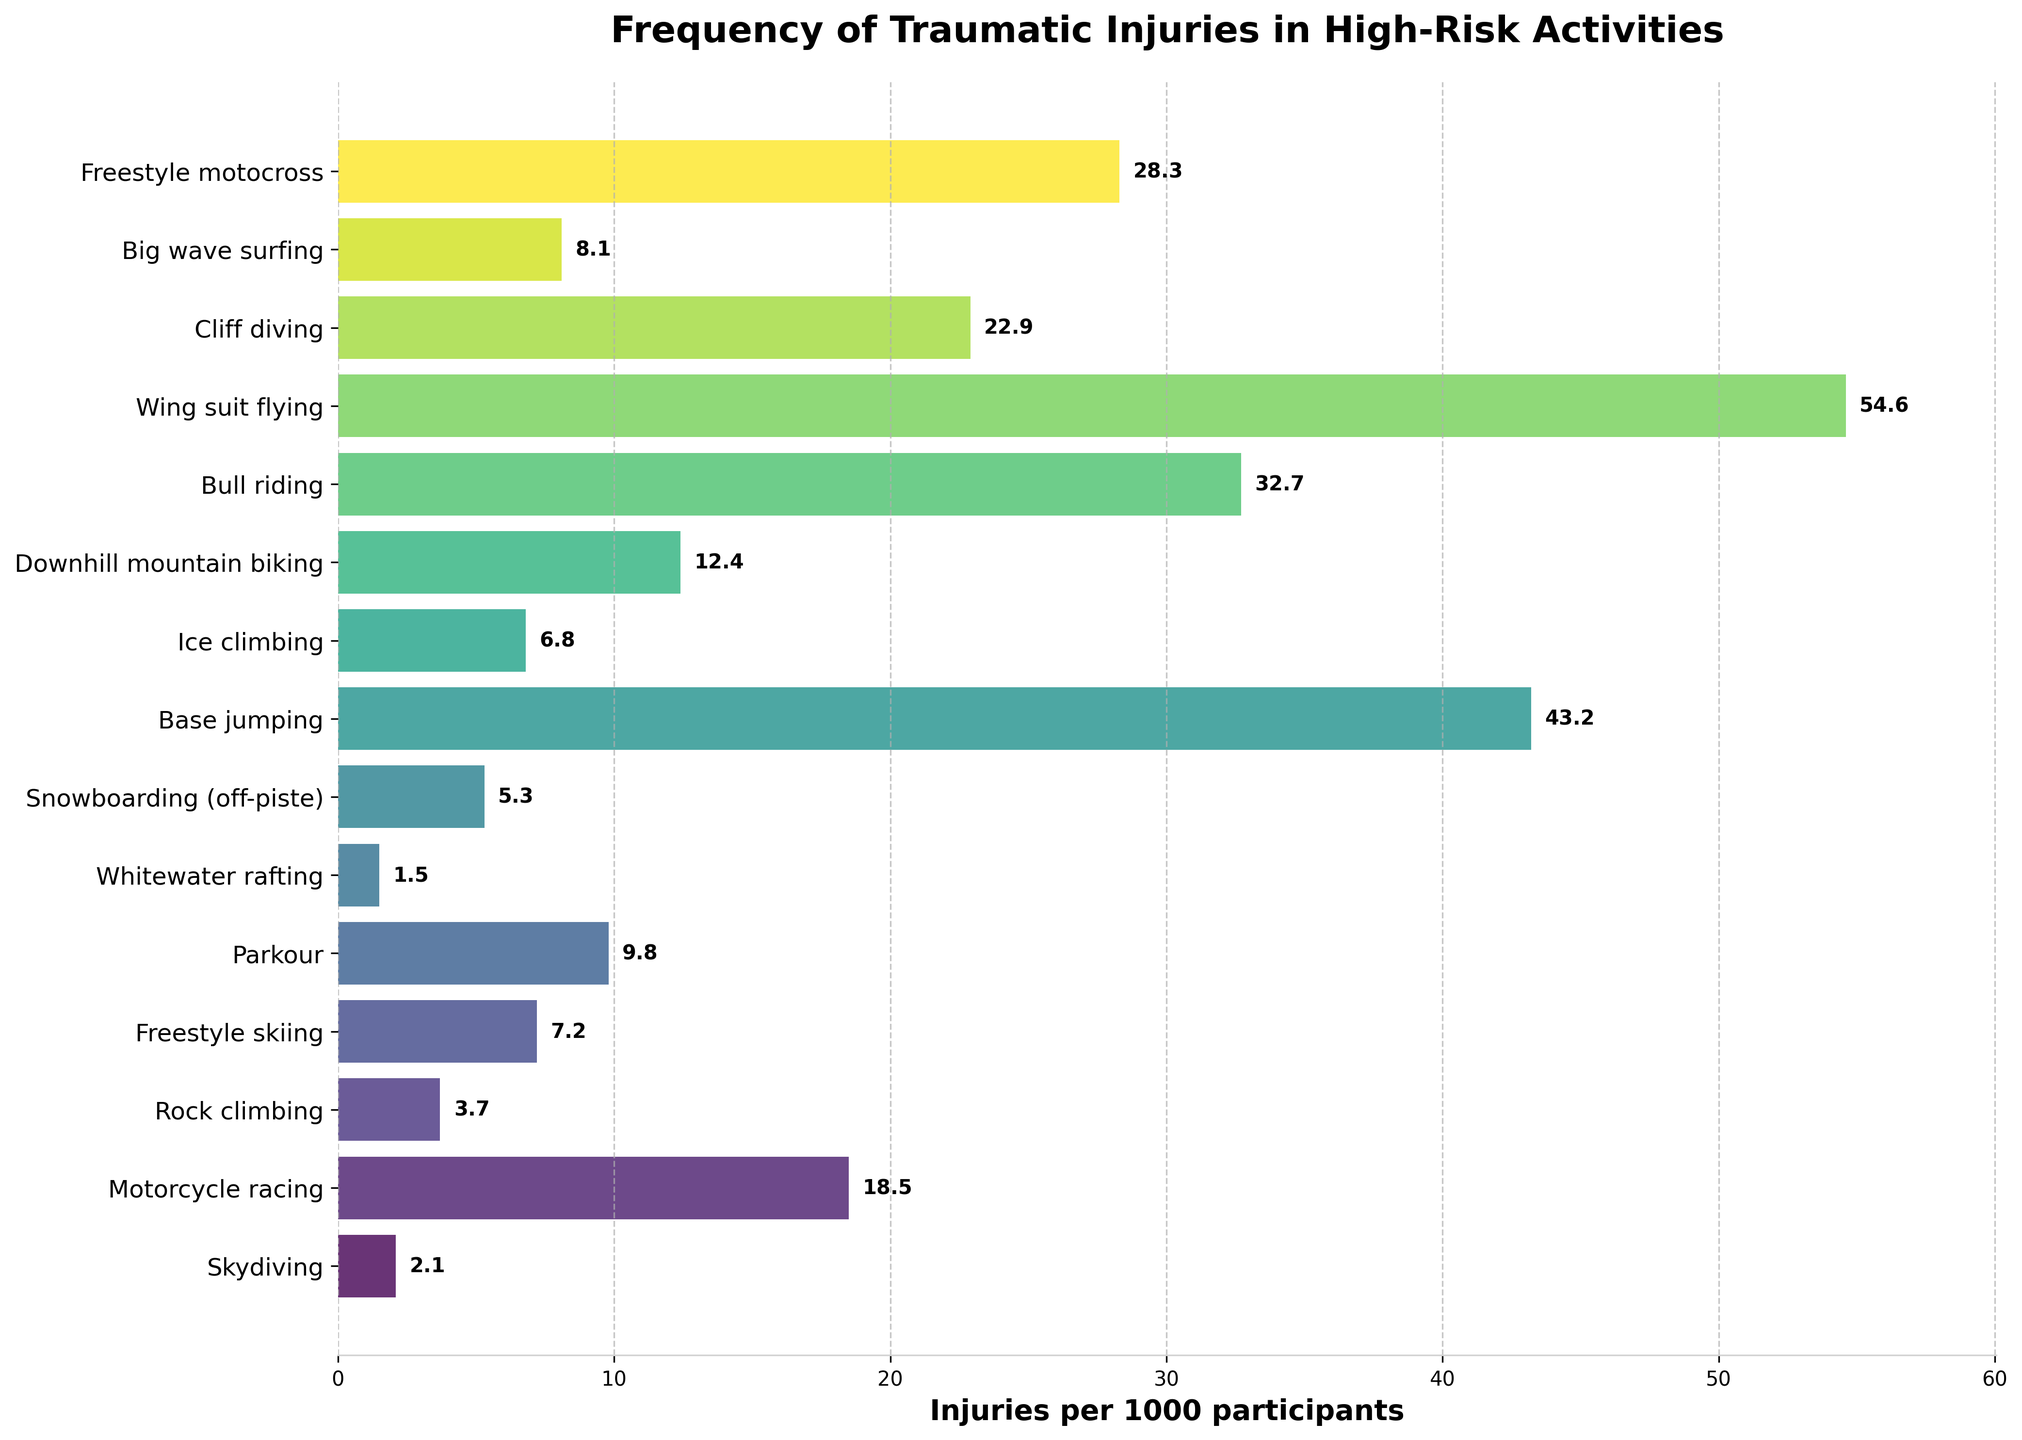Which activity has the highest frequency of injuries? The bar corresponding to Wing suit flying extends farthest to the right, indicating that it has the highest injuries per 1000 participants.
Answer: Wing suit flying Which activity has fewer injuries per 1000 participants: Snowboarding (off-piste) or Big wave surfing? The bar for Snowboarding (off-piste) is shorter than the bar for Big wave surfing, indicating fewer injuries per 1000 participants.
Answer: Snowboarding (off-piste) What's the total injury rate if we combine Rock climbing, Parkour, and Ice climbing? Add the values: Rock climbing (3.7), Parkour (9.8), Ice climbing (6.8). So, 3.7 + 9.8 + 6.8 = 20.3.
Answer: 20.3 How much higher is the injury rate for Base jumping compared to Freestyle skiing? Subtract the value of Freestyle skiing (7.2) from Base jumping (43.2): 43.2 - 7.2 = 36.
Answer: 36 Which activity has the lowest frequency of injuries? The bar for Whitewater rafting is the shortest, indicating it has the lowest injuries per 1000 participants.
Answer: Whitewater rafting Among the activities displayed with bars extending beyond the midpoint of the x-axis, which activity has the shortest bar length? Among the activities with bars extending beyond the midpoint, Downhill mountain biking has the shortest bar.
Answer: Downhill mountain biking What's the average injury rate for the activities with injury rates greater than 10 per 1000 participants? The activities are Motorcycle racing (18.5), Parkour (9.8), Downhill mountain biking (12.4), Bull riding (32.7), Base jumping (43.2), Wing suit flying (54.6), Cliff diving (22.9), Freestyle motocross (28.3). First, select the relevant values: 18.5, 12.4, 32.7, 43.2, 54.6, 22.9, 28.3. Then, calculate the average: (18.5 + 12.4 + 32.7 + 43.2 + 54.6 + 22.9 + 28.3) / 7 ≈ 30.8.
Answer: 30.8 Which activity has more injuries per 1000 participants: Freestyle motocross or Cliff diving? The bar for Wing suit flying is longer than the bar for Cliff diving, indicating it has more injuries per 1000 participants.
Answer: Freestyle motocross What is the difference in injury rates between the most and least risky activities? Subtract the least injury rate (Whitewater rafting, 1.5) from the highest injury rate (Wing suit flying, 54.6): 54.6 - 1.5 = 53.1.
Answer: 53.1 Which activity has the second-highest injury rate? The bar corresponding to Base jumping is slightly shorter than that for Wing suit flying but longer than the others, indicating it has the second-highest injury rate.
Answer: Base jumping 